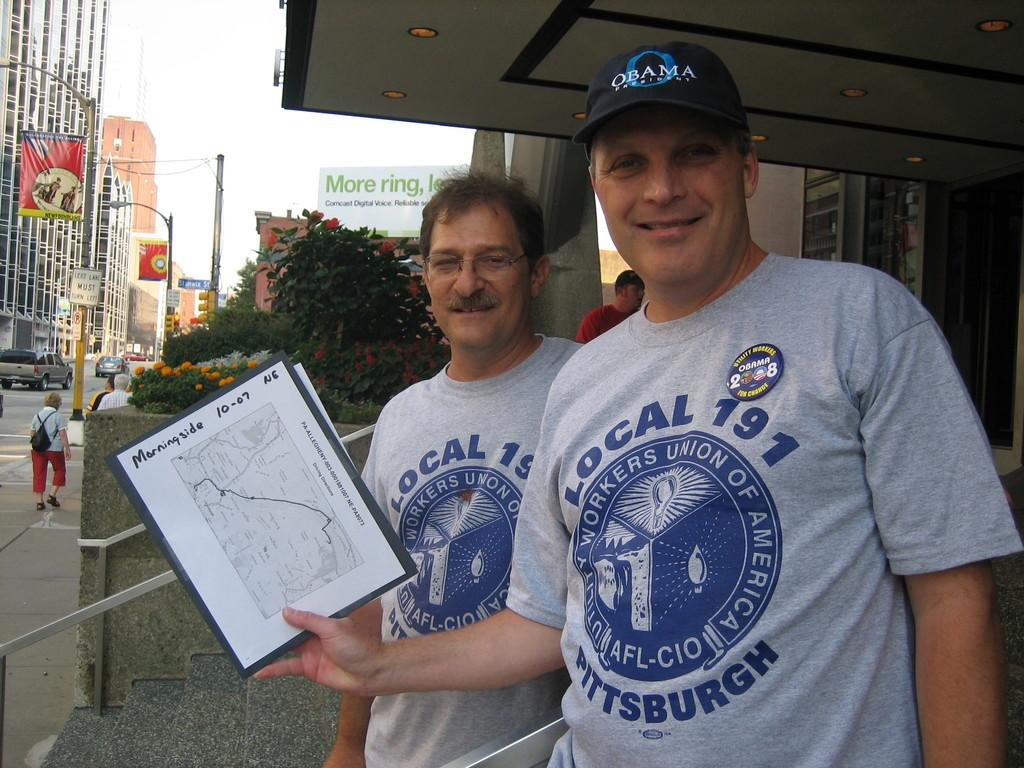<image>
Present a compact description of the photo's key features. Two men posing for a photo with one man holding a booklet that says "Morningside". 